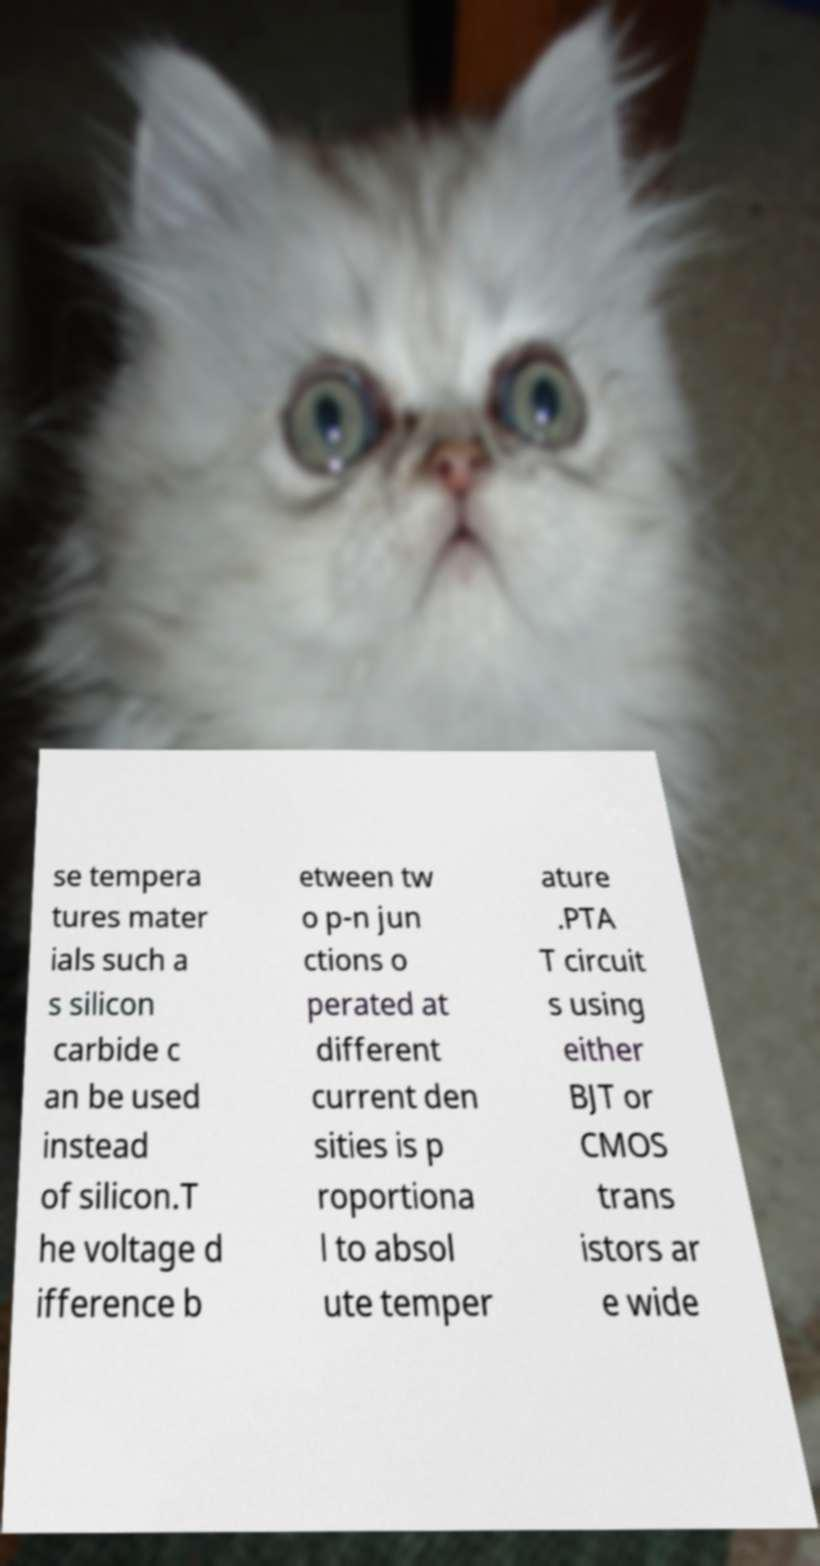For documentation purposes, I need the text within this image transcribed. Could you provide that? se tempera tures mater ials such a s silicon carbide c an be used instead of silicon.T he voltage d ifference b etween tw o p-n jun ctions o perated at different current den sities is p roportiona l to absol ute temper ature .PTA T circuit s using either BJT or CMOS trans istors ar e wide 